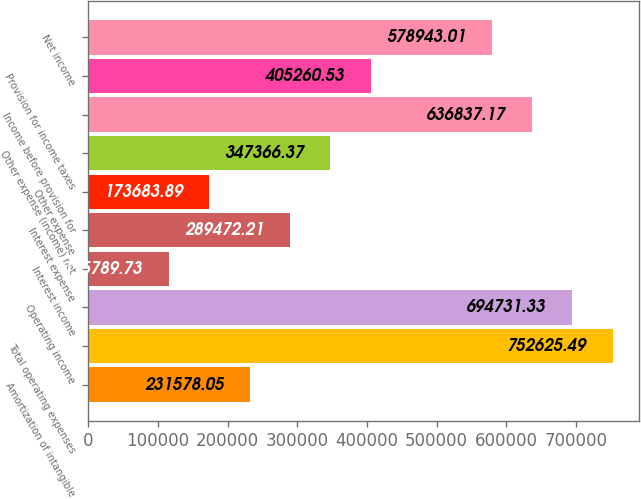<chart> <loc_0><loc_0><loc_500><loc_500><bar_chart><fcel>Amortization of intangible<fcel>Total operating expenses<fcel>Operating income<fcel>Interest income<fcel>Interest expense<fcel>Other expense<fcel>Other expense (income) net<fcel>Income before provision for<fcel>Provision for income taxes<fcel>Net income<nl><fcel>231578<fcel>752625<fcel>694731<fcel>115790<fcel>289472<fcel>173684<fcel>347366<fcel>636837<fcel>405261<fcel>578943<nl></chart> 